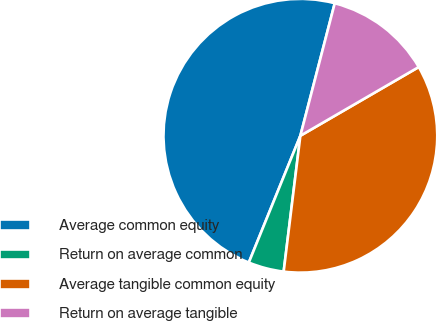<chart> <loc_0><loc_0><loc_500><loc_500><pie_chart><fcel>Average common equity<fcel>Return on average common<fcel>Average tangible common equity<fcel>Return on average tangible<nl><fcel>47.9%<fcel>4.2%<fcel>35.32%<fcel>12.59%<nl></chart> 